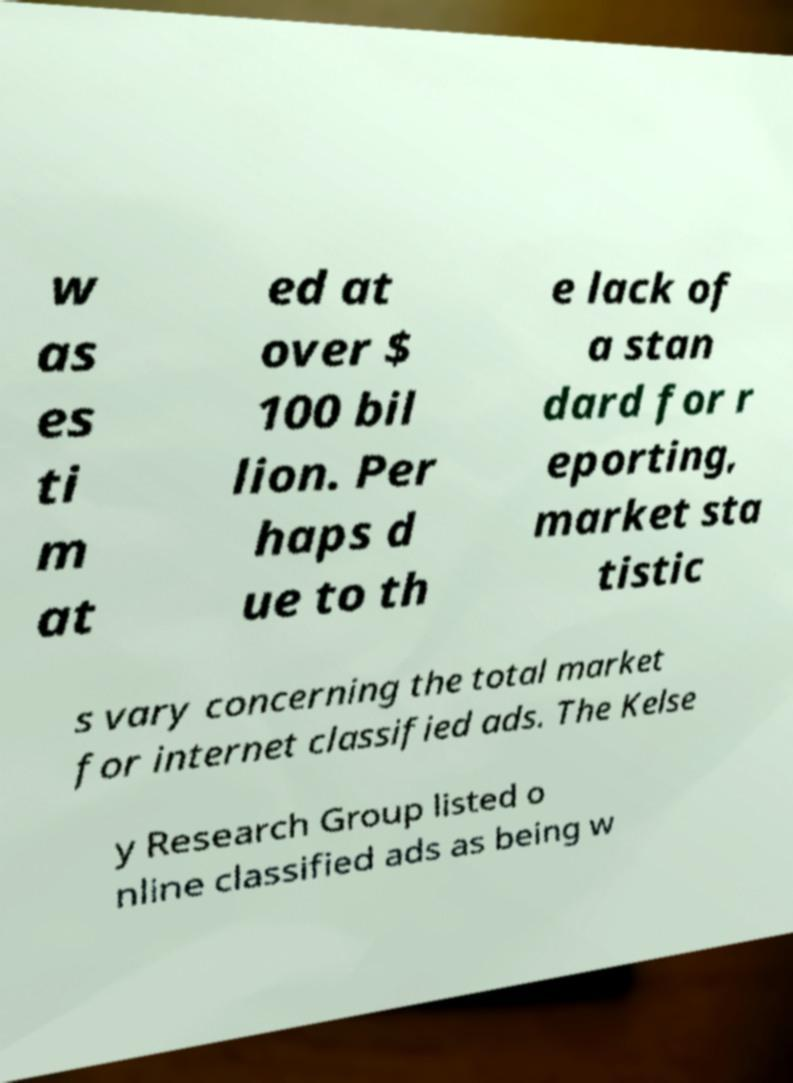Can you accurately transcribe the text from the provided image for me? w as es ti m at ed at over $ 100 bil lion. Per haps d ue to th e lack of a stan dard for r eporting, market sta tistic s vary concerning the total market for internet classified ads. The Kelse y Research Group listed o nline classified ads as being w 